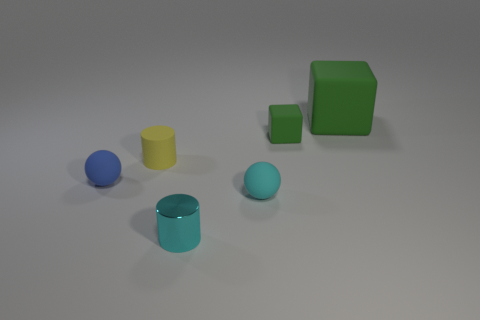There is a rubber sphere that is right of the rubber cylinder; does it have the same size as the small blue ball?
Offer a very short reply. Yes. The thing that is both in front of the blue object and behind the cyan cylinder is what color?
Offer a terse response. Cyan. The cyan metal object that is the same size as the blue sphere is what shape?
Give a very brief answer. Cylinder. Are there any tiny matte things of the same color as the big matte object?
Give a very brief answer. Yes. Are there an equal number of tiny cyan cylinders that are to the right of the large green matte object and small blue objects?
Ensure brevity in your answer.  No. Does the large thing have the same color as the shiny thing?
Your answer should be very brief. No. There is a thing that is both behind the tiny blue object and left of the shiny object; what is its size?
Provide a short and direct response. Small. What color is the cylinder that is made of the same material as the big green object?
Offer a very short reply. Yellow. What number of cubes are made of the same material as the tiny cyan cylinder?
Make the answer very short. 0. Are there the same number of cylinders that are in front of the cyan cylinder and large objects that are in front of the tiny rubber block?
Your answer should be very brief. Yes. 